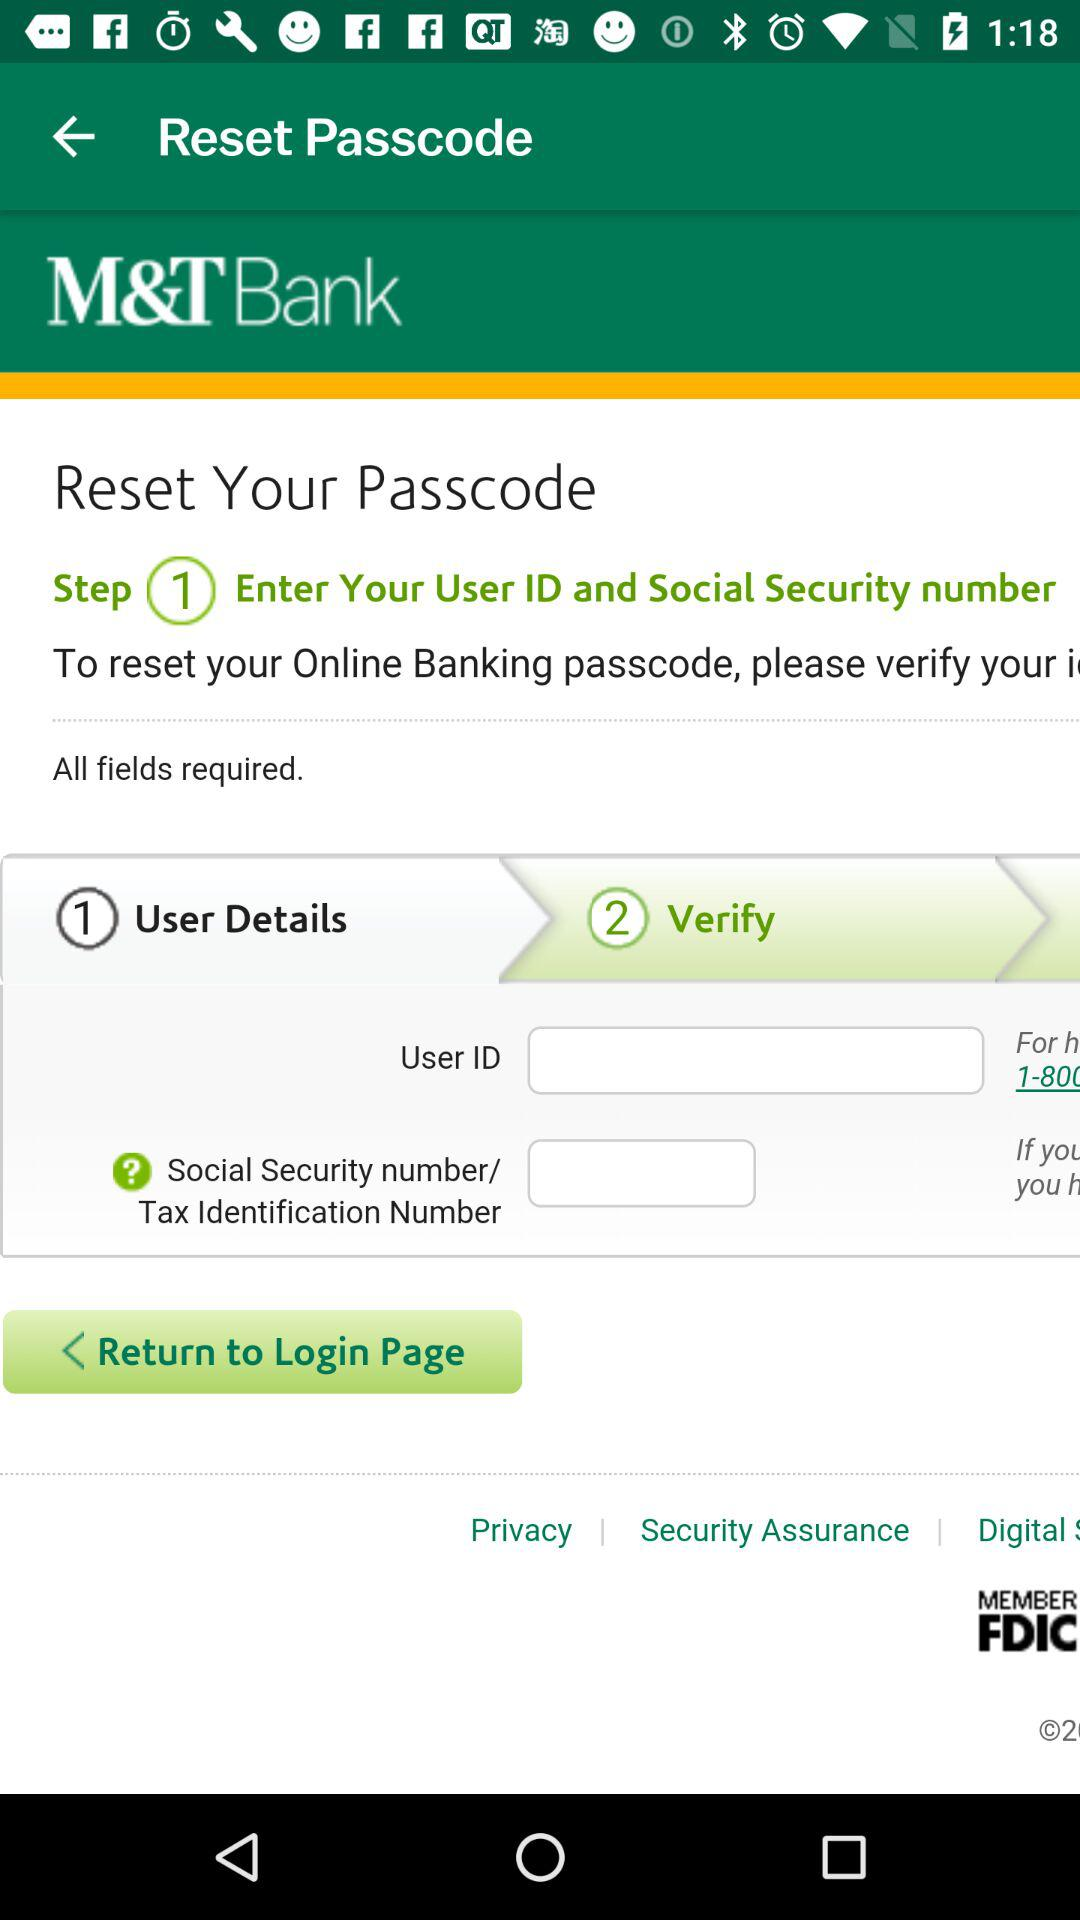What is step 1 for the reset passcode? Step 1 for the reset passcode is "Enter Your User ID and Social Security number". 